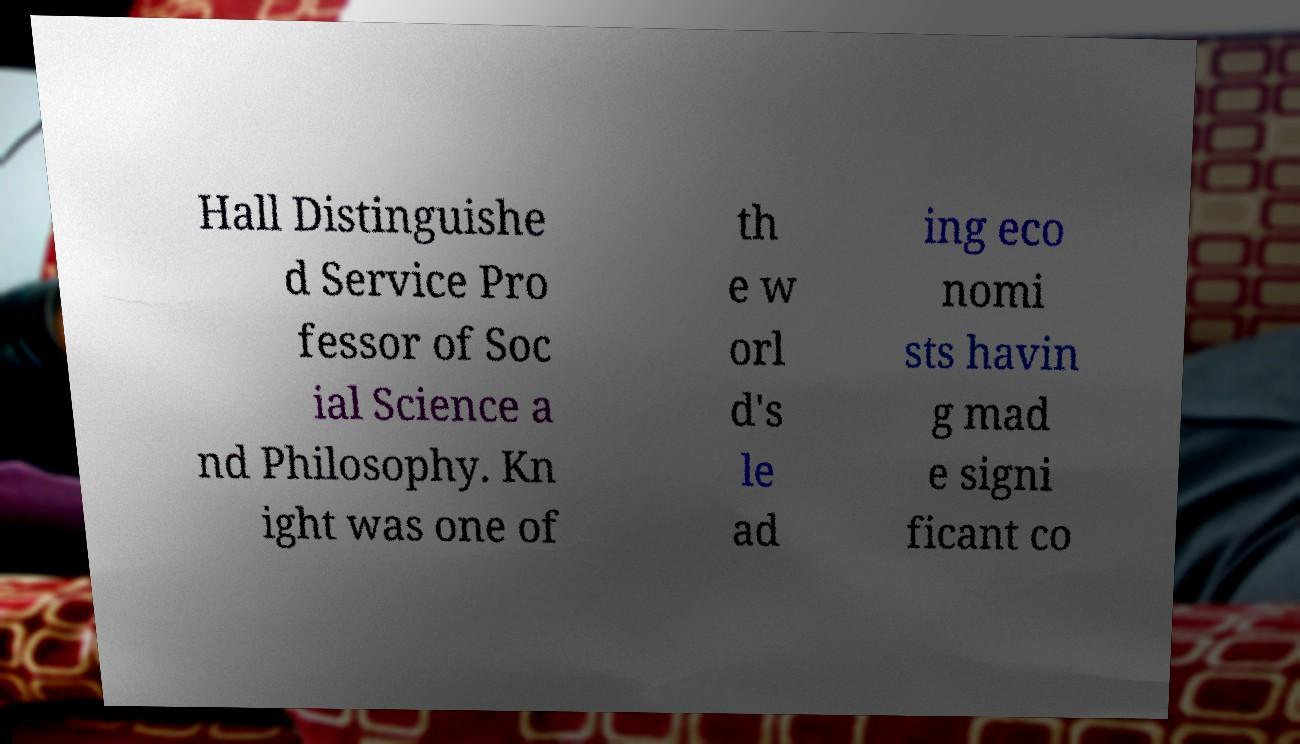Could you extract and type out the text from this image? Hall Distinguishe d Service Pro fessor of Soc ial Science a nd Philosophy. Kn ight was one of th e w orl d's le ad ing eco nomi sts havin g mad e signi ficant co 